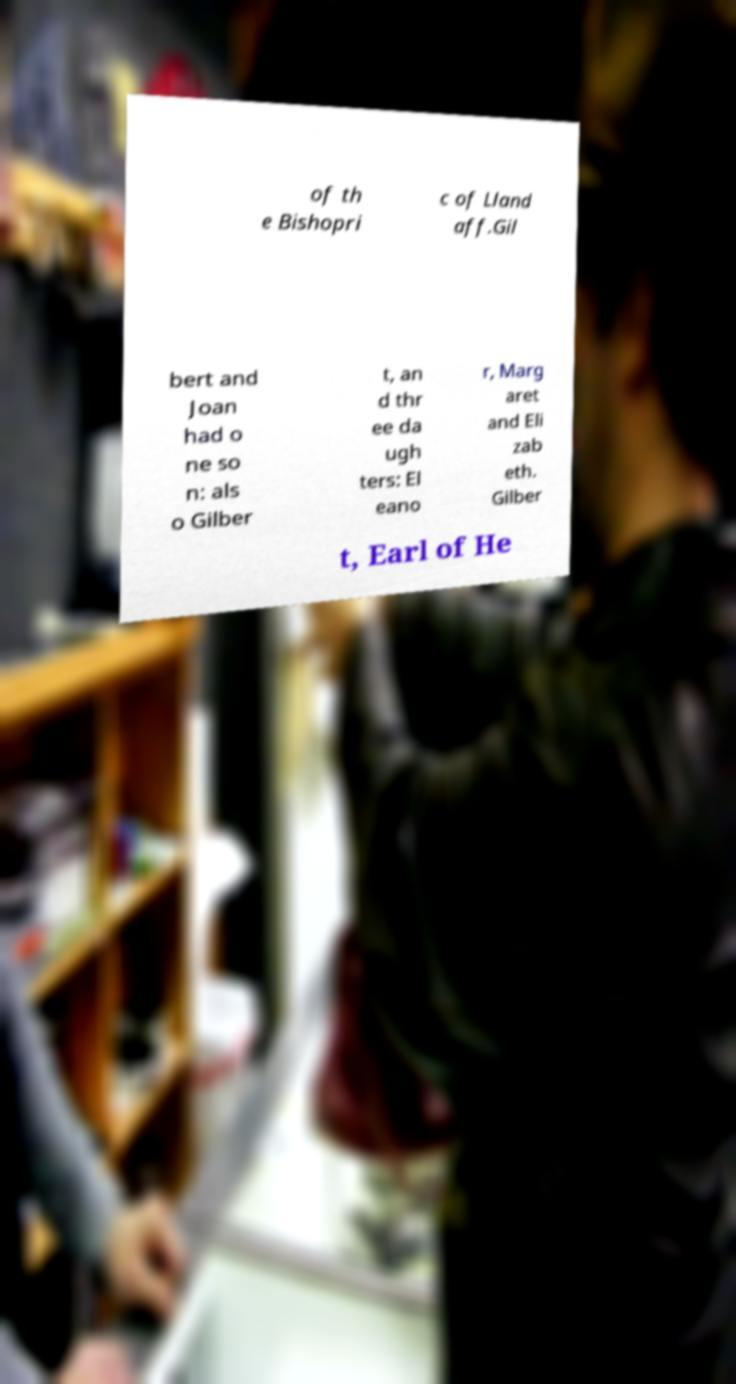There's text embedded in this image that I need extracted. Can you transcribe it verbatim? of th e Bishopri c of Lland aff.Gil bert and Joan had o ne so n: als o Gilber t, an d thr ee da ugh ters: El eano r, Marg aret and Eli zab eth. Gilber t, Earl of He 